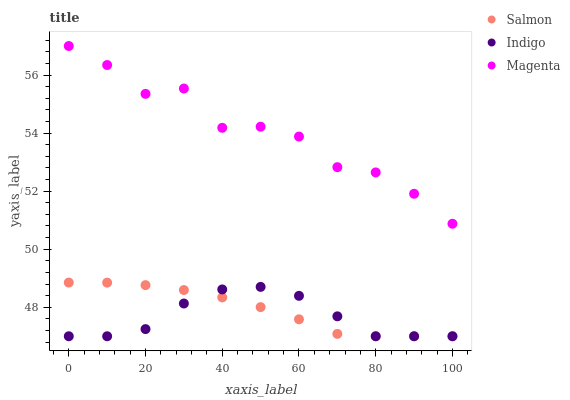Does Indigo have the minimum area under the curve?
Answer yes or no. Yes. Does Magenta have the maximum area under the curve?
Answer yes or no. Yes. Does Salmon have the minimum area under the curve?
Answer yes or no. No. Does Salmon have the maximum area under the curve?
Answer yes or no. No. Is Salmon the smoothest?
Answer yes or no. Yes. Is Magenta the roughest?
Answer yes or no. Yes. Is Magenta the smoothest?
Answer yes or no. No. Is Salmon the roughest?
Answer yes or no. No. Does Indigo have the lowest value?
Answer yes or no. Yes. Does Magenta have the lowest value?
Answer yes or no. No. Does Magenta have the highest value?
Answer yes or no. Yes. Does Salmon have the highest value?
Answer yes or no. No. Is Indigo less than Magenta?
Answer yes or no. Yes. Is Magenta greater than Indigo?
Answer yes or no. Yes. Does Indigo intersect Salmon?
Answer yes or no. Yes. Is Indigo less than Salmon?
Answer yes or no. No. Is Indigo greater than Salmon?
Answer yes or no. No. Does Indigo intersect Magenta?
Answer yes or no. No. 